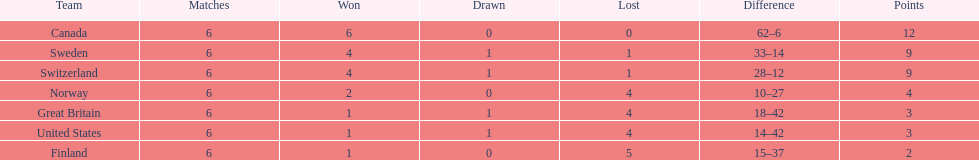Which team won more matches, finland or norway? Norway. 